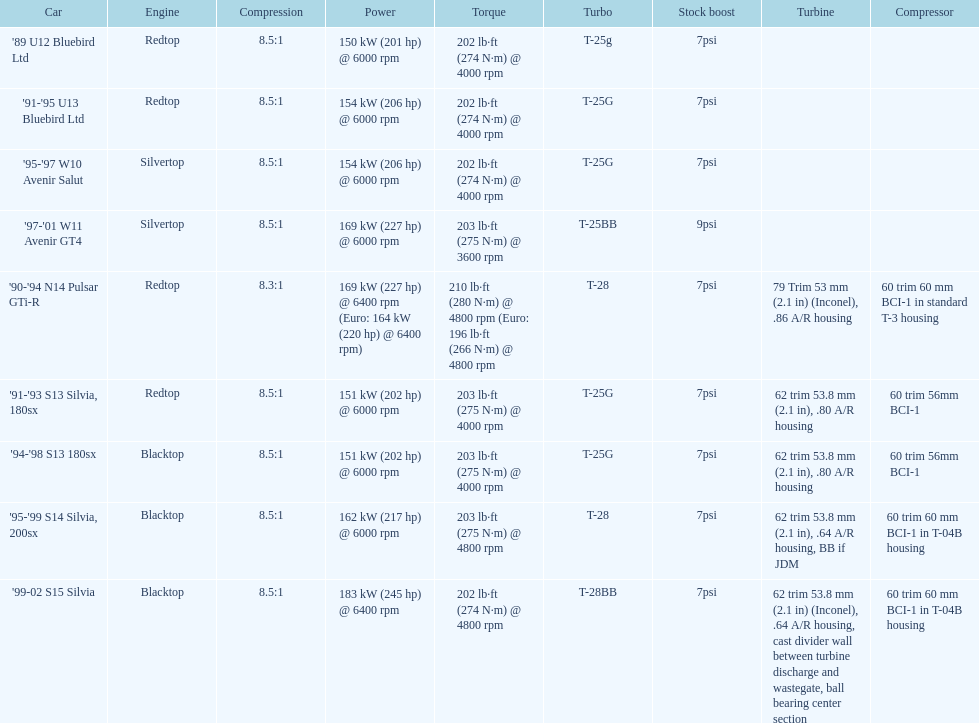Parse the table in full. {'header': ['Car', 'Engine', 'Compression', 'Power', 'Torque', 'Turbo', 'Stock boost', 'Turbine', 'Compressor'], 'rows': [["'89 U12 Bluebird Ltd", 'Redtop', '8.5:1', '150\xa0kW (201\xa0hp) @ 6000 rpm', '202\xa0lb·ft (274\xa0N·m) @ 4000 rpm', 'T-25g', '7psi', '', ''], ["'91-'95 U13 Bluebird Ltd", 'Redtop', '8.5:1', '154\xa0kW (206\xa0hp) @ 6000 rpm', '202\xa0lb·ft (274\xa0N·m) @ 4000 rpm', 'T-25G', '7psi', '', ''], ["'95-'97 W10 Avenir Salut", 'Silvertop', '8.5:1', '154\xa0kW (206\xa0hp) @ 6000 rpm', '202\xa0lb·ft (274\xa0N·m) @ 4000 rpm', 'T-25G', '7psi', '', ''], ["'97-'01 W11 Avenir GT4", 'Silvertop', '8.5:1', '169\xa0kW (227\xa0hp) @ 6000 rpm', '203\xa0lb·ft (275\xa0N·m) @ 3600 rpm', 'T-25BB', '9psi', '', ''], ["'90-'94 N14 Pulsar GTi-R", 'Redtop', '8.3:1', '169\xa0kW (227\xa0hp) @ 6400 rpm (Euro: 164\xa0kW (220\xa0hp) @ 6400 rpm)', '210\xa0lb·ft (280\xa0N·m) @ 4800 rpm (Euro: 196\xa0lb·ft (266\xa0N·m) @ 4800 rpm', 'T-28', '7psi', '79 Trim 53\xa0mm (2.1\xa0in) (Inconel), .86 A/R housing', '60 trim 60\xa0mm BCI-1 in standard T-3 housing'], ["'91-'93 S13 Silvia, 180sx", 'Redtop', '8.5:1', '151\xa0kW (202\xa0hp) @ 6000 rpm', '203\xa0lb·ft (275\xa0N·m) @ 4000 rpm', 'T-25G', '7psi', '62 trim 53.8\xa0mm (2.1\xa0in), .80 A/R housing', '60 trim 56mm BCI-1'], ["'94-'98 S13 180sx", 'Blacktop', '8.5:1', '151\xa0kW (202\xa0hp) @ 6000 rpm', '203\xa0lb·ft (275\xa0N·m) @ 4000 rpm', 'T-25G', '7psi', '62 trim 53.8\xa0mm (2.1\xa0in), .80 A/R housing', '60 trim 56mm BCI-1'], ["'95-'99 S14 Silvia, 200sx", 'Blacktop', '8.5:1', '162\xa0kW (217\xa0hp) @ 6000 rpm', '203\xa0lb·ft (275\xa0N·m) @ 4800 rpm', 'T-28', '7psi', '62 trim 53.8\xa0mm (2.1\xa0in), .64 A/R housing, BB if JDM', '60 trim 60\xa0mm BCI-1 in T-04B housing'], ["'99-02 S15 Silvia", 'Blacktop', '8.5:1', '183\xa0kW (245\xa0hp) @ 6400 rpm', '202\xa0lb·ft (274\xa0N·m) @ 4800 rpm', 'T-28BB', '7psi', '62 trim 53.8\xa0mm (2.1\xa0in) (Inconel), .64 A/R housing, cast divider wall between turbine discharge and wastegate, ball bearing center section', '60 trim 60\xa0mm BCI-1 in T-04B housing']]} Which engines were employed post-1999? Silvertop, Blacktop. 